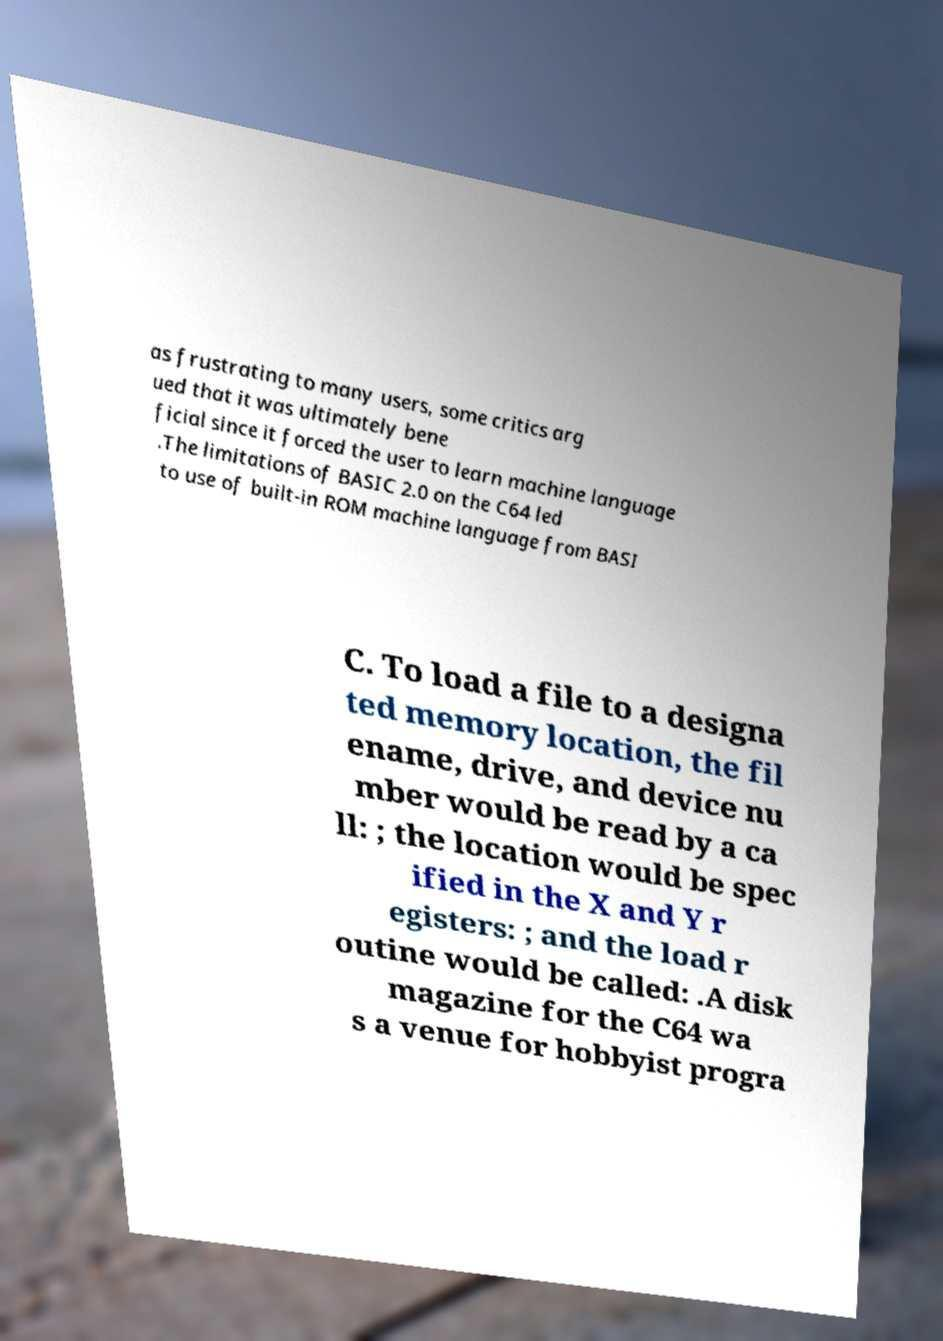What messages or text are displayed in this image? I need them in a readable, typed format. as frustrating to many users, some critics arg ued that it was ultimately bene ficial since it forced the user to learn machine language .The limitations of BASIC 2.0 on the C64 led to use of built-in ROM machine language from BASI C. To load a file to a designa ted memory location, the fil ename, drive, and device nu mber would be read by a ca ll: ; the location would be spec ified in the X and Y r egisters: ; and the load r outine would be called: .A disk magazine for the C64 wa s a venue for hobbyist progra 